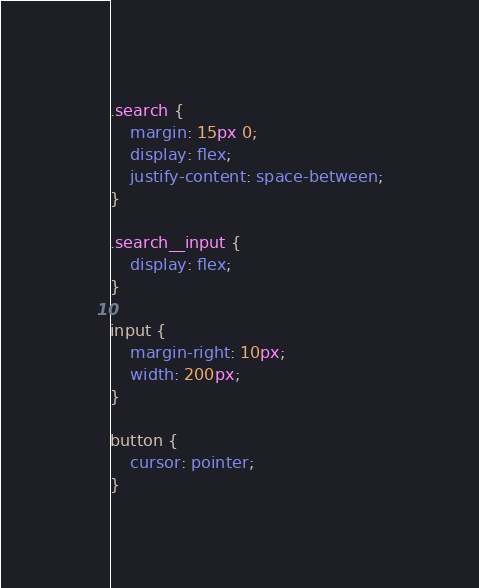Convert code to text. <code><loc_0><loc_0><loc_500><loc_500><_CSS_>.search {
	margin: 15px 0;
	display: flex;
	justify-content: space-between;
}

.search__input {
	display: flex;
}

input {
	margin-right: 10px;
	width: 200px;
}

button {
	cursor: pointer;
}
</code> 